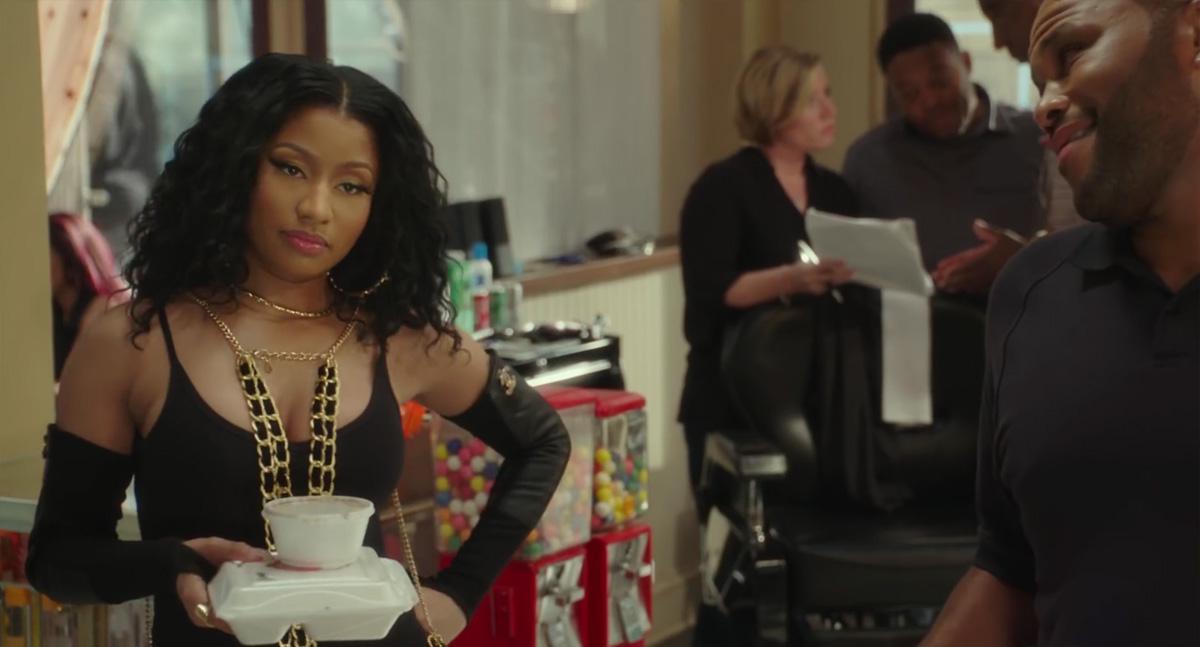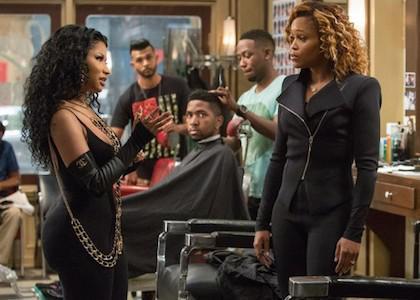The first image is the image on the left, the second image is the image on the right. Considering the images on both sides, is "A female wearing black stands in the foreground of the image on the left." valid? Answer yes or no. Yes. 